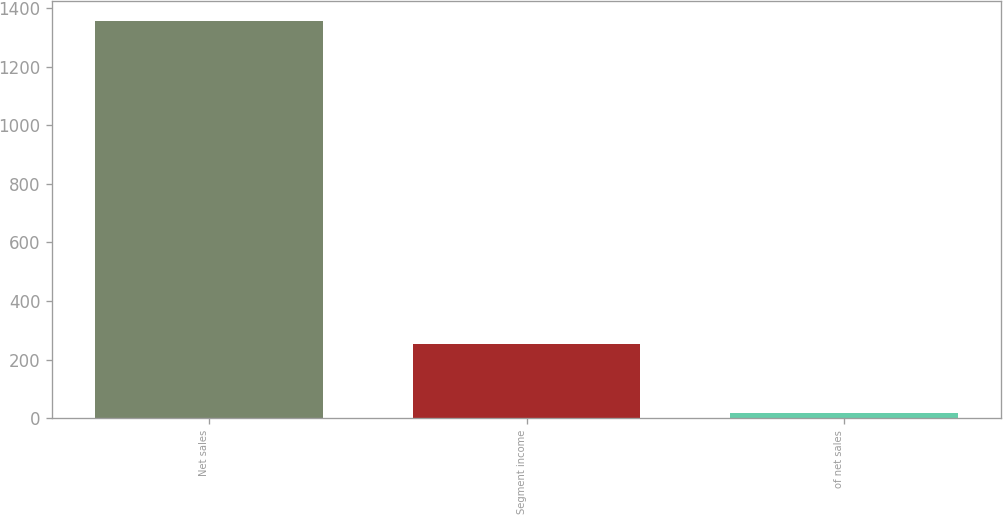Convert chart. <chart><loc_0><loc_0><loc_500><loc_500><bar_chart><fcel>Net sales<fcel>Segment income<fcel>of net sales<nl><fcel>1356.4<fcel>253.3<fcel>18.7<nl></chart> 